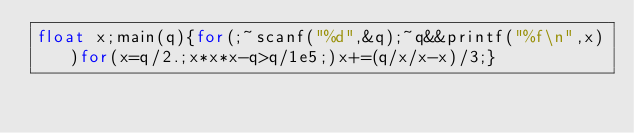<code> <loc_0><loc_0><loc_500><loc_500><_C_>float x;main(q){for(;~scanf("%d",&q);~q&&printf("%f\n",x))for(x=q/2.;x*x*x-q>q/1e5;)x+=(q/x/x-x)/3;}</code> 